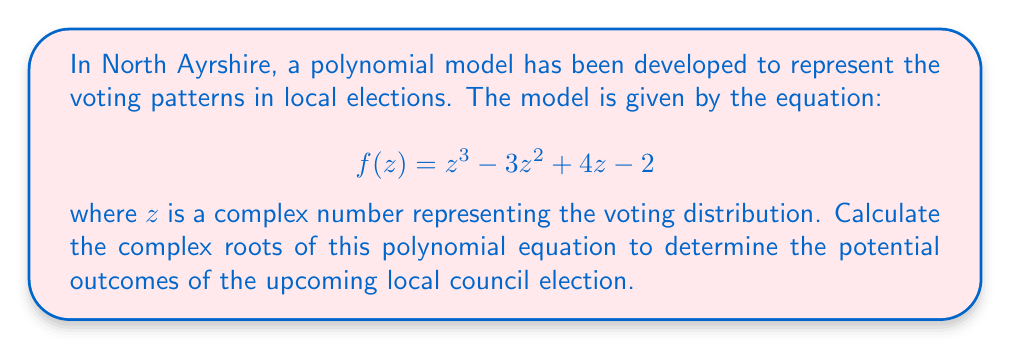Show me your answer to this math problem. To find the complex roots of the polynomial equation $f(z) = z^3 - 3z^2 + 4z - 2$, we can use the following steps:

1. Recognize that this is a cubic equation in the form $az^3 + bz^2 + cz + d = 0$, where $a=1$, $b=-3$, $c=4$, and $d=-2$.

2. Use Cardano's formula for cubic equations. First, calculate the following:

   $p = \frac{3ac-b^2}{3a^2} = \frac{3(1)(4)-(-3)^2}{3(1)^2} = \frac{12-9}{3} = 1$
   
   $q = \frac{2b^3-9abc+27a^2d}{27a^3} = \frac{2(-3)^3-9(1)(-3)(4)+27(1)^2(-2)}{27(1)^3} = \frac{-54+108-54}{27} = 0$

3. Calculate the discriminant $\Delta = (\frac{q}{2})^2 + (\frac{p}{3})^3 = 0^2 + (\frac{1}{3})^3 = \frac{1}{27}$

4. Since $\Delta > 0$, there will be one real root and two complex conjugate roots.

5. Calculate the cube roots:
   
   $u = \sqrt[3]{-\frac{q}{2} + \sqrt{\Delta}} = \sqrt[3]{\frac{1}{3}} = \frac{1}{\sqrt[3]{3}}$
   
   $v = \sqrt[3]{-\frac{q}{2} - \sqrt{\Delta}} = -\frac{1}{\sqrt[3]{3}}$

6. The roots are given by:

   $z_1 = u + v - \frac{b}{3a} = \frac{1}{\sqrt[3]{3}} - \frac{1}{\sqrt[3]{3}} - \frac{-3}{3} = 1$
   
   $z_2 = -\frac{1}{2}(u+v) - \frac{b}{3a} + i\frac{\sqrt{3}}{2}(u-v) = -\frac{1}{2}(0) + 1 + i\frac{\sqrt{3}}{2}(\frac{2}{\sqrt[3]{3}}) = 1 + i\sqrt{3}$
   
   $z_3 = -\frac{1}{2}(u+v) - \frac{b}{3a} - i\frac{\sqrt{3}}{2}(u-v) = -\frac{1}{2}(0) + 1 - i\frac{\sqrt{3}}{2}(\frac{2}{\sqrt[3]{3}}) = 1 - i\sqrt{3}$
Answer: $z_1 = 1$, $z_2 = 1 + i\sqrt{3}$, $z_3 = 1 - i\sqrt{3}$ 